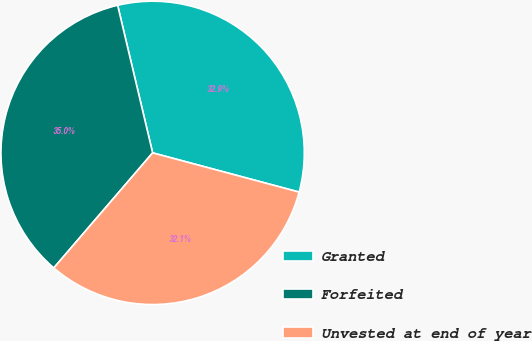Convert chart. <chart><loc_0><loc_0><loc_500><loc_500><pie_chart><fcel>Granted<fcel>Forfeited<fcel>Unvested at end of year<nl><fcel>32.87%<fcel>35.0%<fcel>32.13%<nl></chart> 